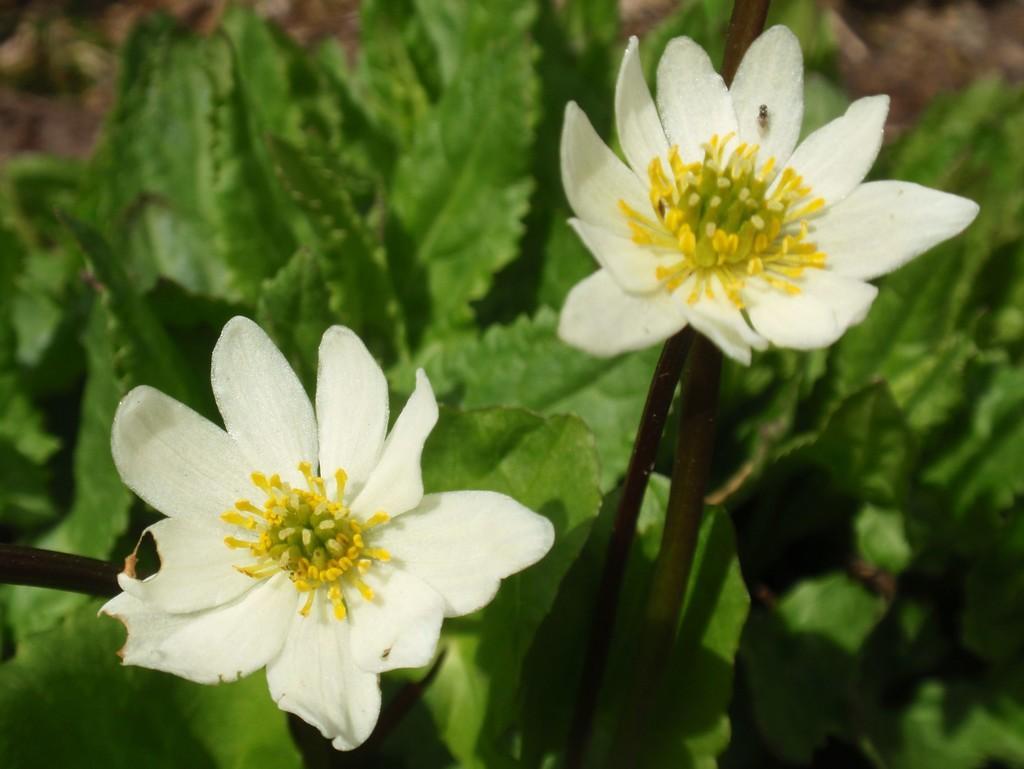Could you give a brief overview of what you see in this image? In this image there are white flowers and leaves. 